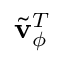Convert formula to latex. <formula><loc_0><loc_0><loc_500><loc_500>\tilde { v } _ { \phi } ^ { T }</formula> 